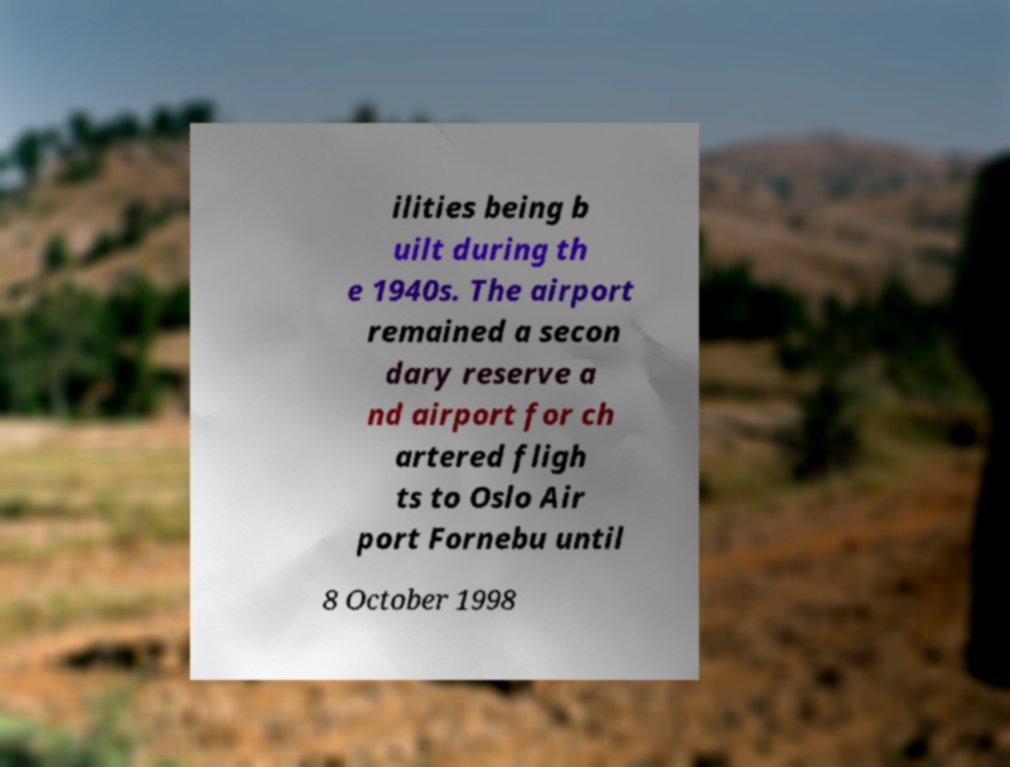Can you accurately transcribe the text from the provided image for me? ilities being b uilt during th e 1940s. The airport remained a secon dary reserve a nd airport for ch artered fligh ts to Oslo Air port Fornebu until 8 October 1998 